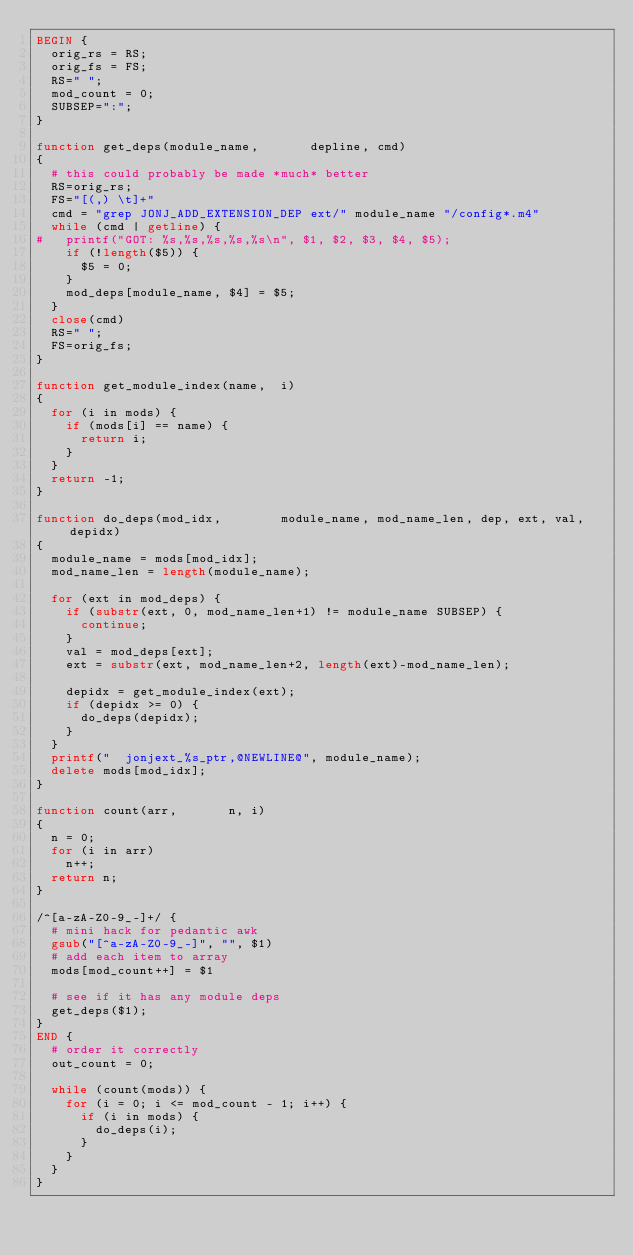<code> <loc_0><loc_0><loc_500><loc_500><_Awk_>BEGIN {
	orig_rs = RS;
	orig_fs = FS;
	RS=" ";
	mod_count = 0;
	SUBSEP=":";
}

function get_deps(module_name,       depline, cmd)
{
	# this could probably be made *much* better
	RS=orig_rs;
	FS="[(,) \t]+"
	cmd = "grep JONJ_ADD_EXTENSION_DEP ext/" module_name "/config*.m4"
	while (cmd | getline) {
#		printf("GOT: %s,%s,%s,%s,%s\n", $1, $2, $3, $4, $5);
		if (!length($5)) {
			$5 = 0;
		}
		mod_deps[module_name, $4] = $5;
	}
	close(cmd)
	RS=" ";
	FS=orig_fs;
}

function get_module_index(name,  i)
{
	for (i in mods) {
		if (mods[i] == name) {
			return i;
		}
	}
	return -1;
}

function do_deps(mod_idx,        module_name, mod_name_len, dep, ext, val, depidx)
{
	module_name = mods[mod_idx];
	mod_name_len = length(module_name);

	for (ext in mod_deps) {
		if (substr(ext, 0, mod_name_len+1) != module_name SUBSEP) {
			continue;
		}
		val = mod_deps[ext];
		ext = substr(ext, mod_name_len+2, length(ext)-mod_name_len);

		depidx = get_module_index(ext);
		if (depidx >= 0) {
			do_deps(depidx);
		}
	}
	printf("	jonjext_%s_ptr,@NEWLINE@", module_name);
	delete mods[mod_idx];
}

function count(arr,       n, i)
{
	n = 0;
	for (i in arr)
		n++;
	return n;
}

/^[a-zA-Z0-9_-]+/ {
	# mini hack for pedantic awk
	gsub("[^a-zA-Z0-9_-]", "", $1)
	# add each item to array
	mods[mod_count++] = $1

	# see if it has any module deps
	get_deps($1);
}
END {
	# order it correctly
	out_count = 0;
	
	while (count(mods)) {
		for (i = 0; i <= mod_count - 1; i++) {
			if (i in mods) {
				do_deps(i);
			}
		}
	}
}
</code> 